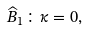<formula> <loc_0><loc_0><loc_500><loc_500>\widehat { B } _ { 1 } \colon \kappa = 0 ,</formula> 